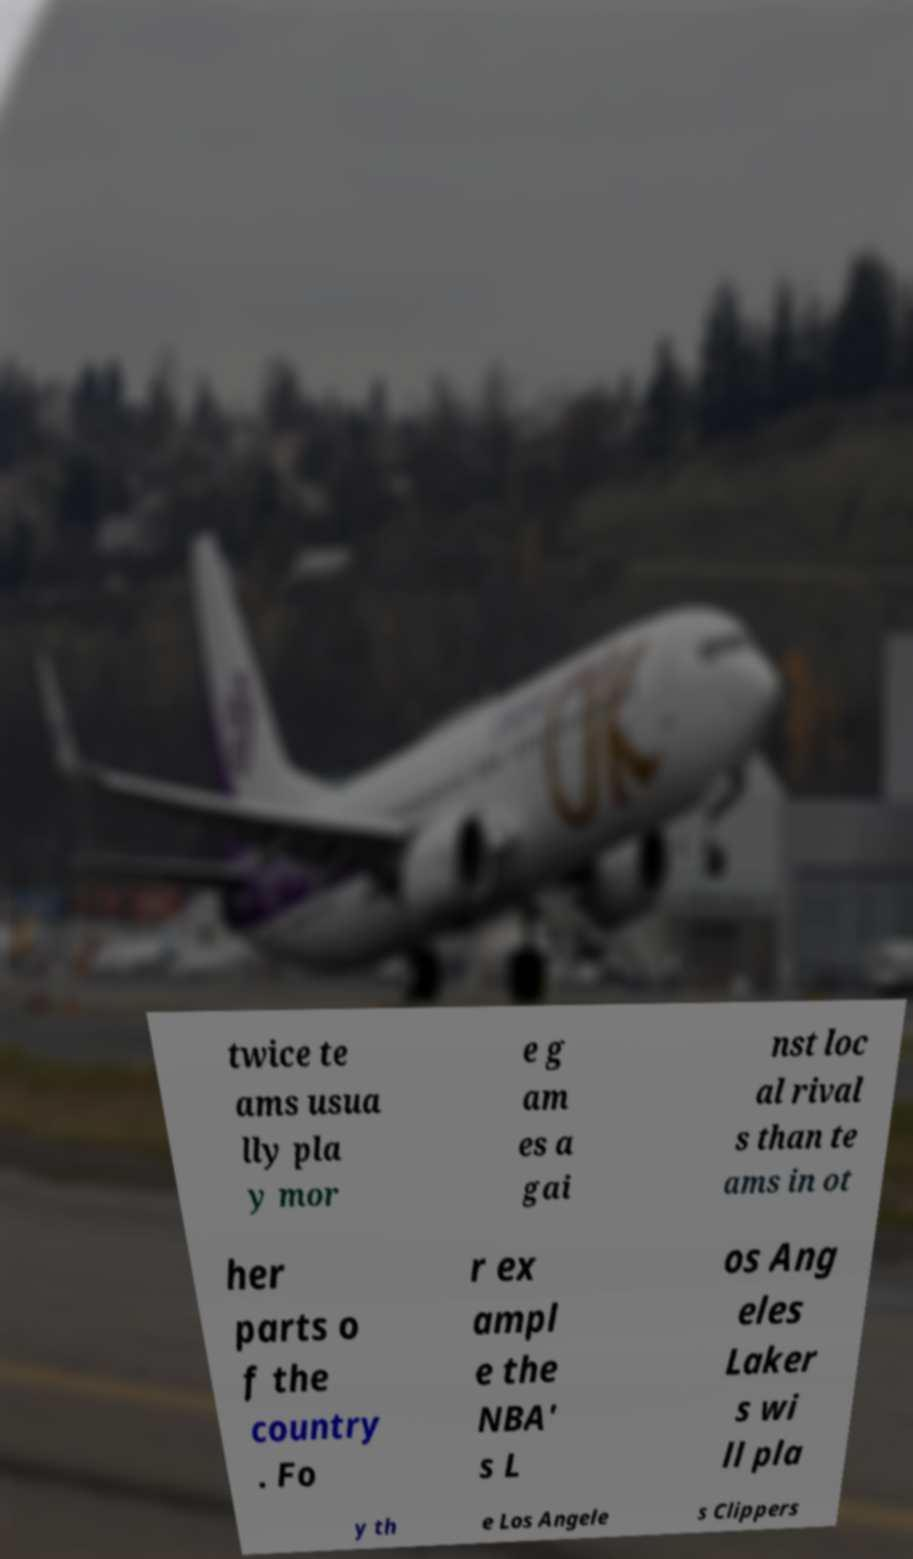Please read and relay the text visible in this image. What does it say? twice te ams usua lly pla y mor e g am es a gai nst loc al rival s than te ams in ot her parts o f the country . Fo r ex ampl e the NBA' s L os Ang eles Laker s wi ll pla y th e Los Angele s Clippers 